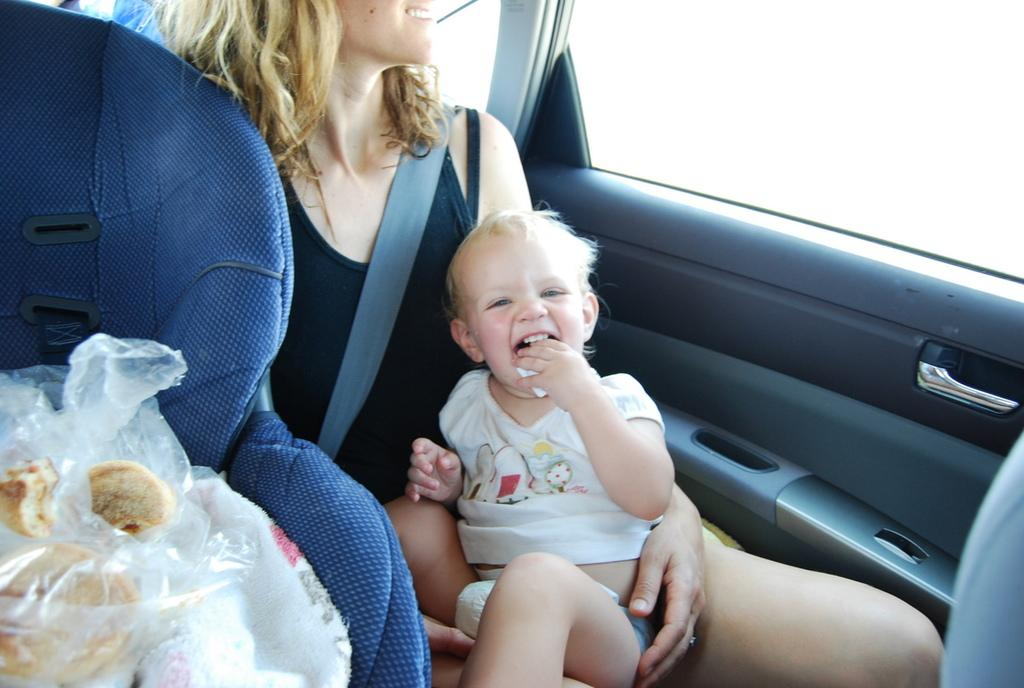Who is present in the image? There is a woman in the image. What is the woman doing in the image? The woman is sitting in a vehicle and holding a baby. What can be seen on the left side of the image? There is a baby stroller on the left side of the image. What items are inside the baby stroller? There are clothes and food in the baby stroller. What type of basketball game is being played in the image? There is no basketball game present in the image. How many dolls are visible in the image? There are no dolls visible in the image. 